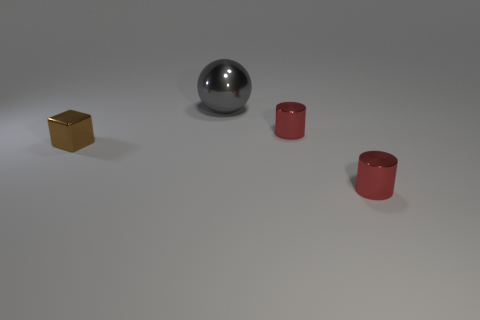What size is the brown metallic object?
Your response must be concise. Small. How many large shiny things are on the left side of the tiny metal thing to the left of the gray object?
Provide a succinct answer. 0. How many other small cubes are the same color as the tiny cube?
Give a very brief answer. 0. Are there any large gray metal balls that are to the right of the tiny metallic thing that is in front of the metallic object on the left side of the big gray sphere?
Provide a short and direct response. No. What is the size of the object that is both behind the tiny brown cube and in front of the gray shiny sphere?
Offer a very short reply. Small. How many big gray objects are the same material as the brown object?
Give a very brief answer. 1. How many blocks are either metal objects or small brown rubber objects?
Your response must be concise. 1. There is a shiny thing that is on the left side of the gray metal object behind the tiny metallic object that is in front of the cube; what size is it?
Make the answer very short. Small. What is the color of the thing that is behind the brown metal block and on the right side of the gray metal sphere?
Offer a very short reply. Red. Does the gray object have the same size as the red cylinder that is behind the block?
Provide a short and direct response. No. 